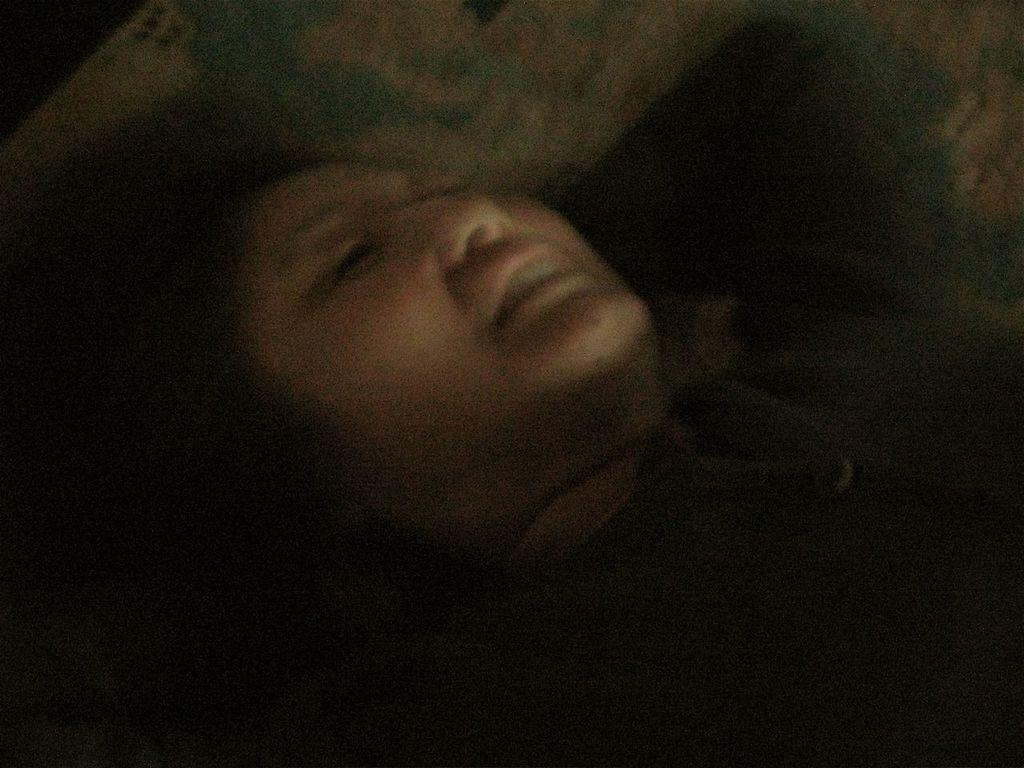Who is present in the image? There is a woman in the image. What is the woman doing in the image? The woman is laying on a bed. What type of grip does the woman have on the bushes in the image? There are no bushes present in the image, and the woman is laying on a bed, not gripping anything. 